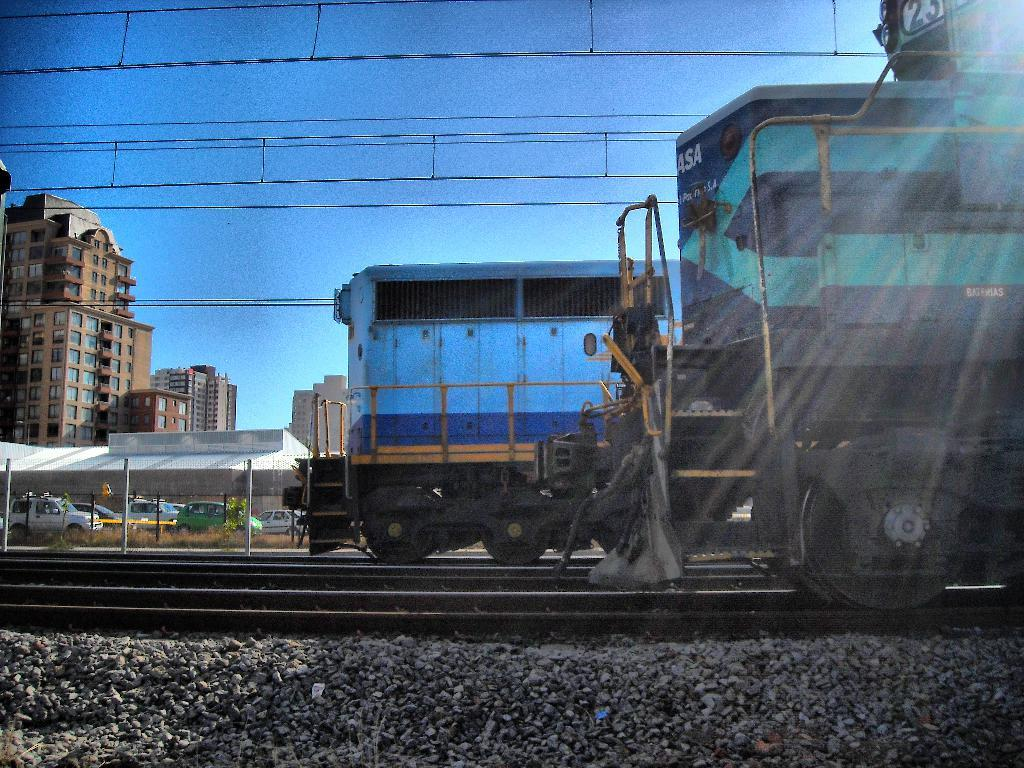What is present on the railway tracks in the image? There are trains on the railway tracks. What can be seen in the background of the image? There are vehicles, grass, buildings, cables, and the sky visible in the background. How many types of transportation are visible in the image? There are trains and vehicles visible in the image. What type of environment is depicted in the background? The background features a mix of urban and natural elements, including buildings, grass, and the sky. What year is depicted in the image? The image does not depict a specific year; it is a photograph of a scene that could be from any time. 